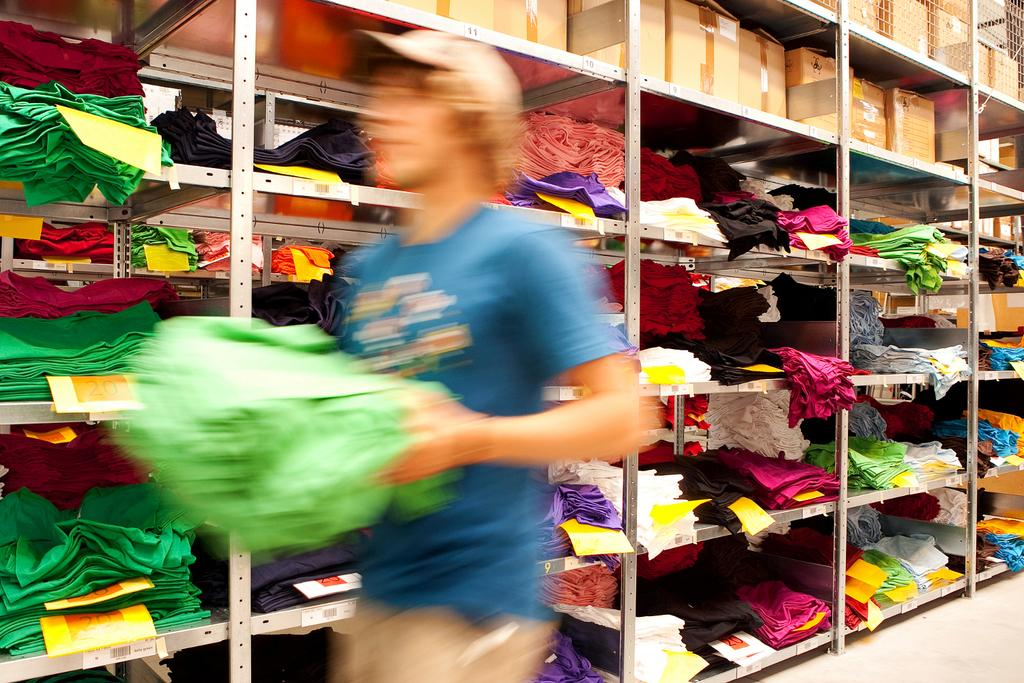What is the person in the image doing? The person is standing in the image and holding clothes. What else can be seen in the image besides the person? There are cardboard boxes in the background of the image, and there are clothes with price papers in the racks in the background. What type of haircut does the person have in the image? There is no information about the person's haircut in the image. Can you see a train in the background of the image? There is no train present in the image. 